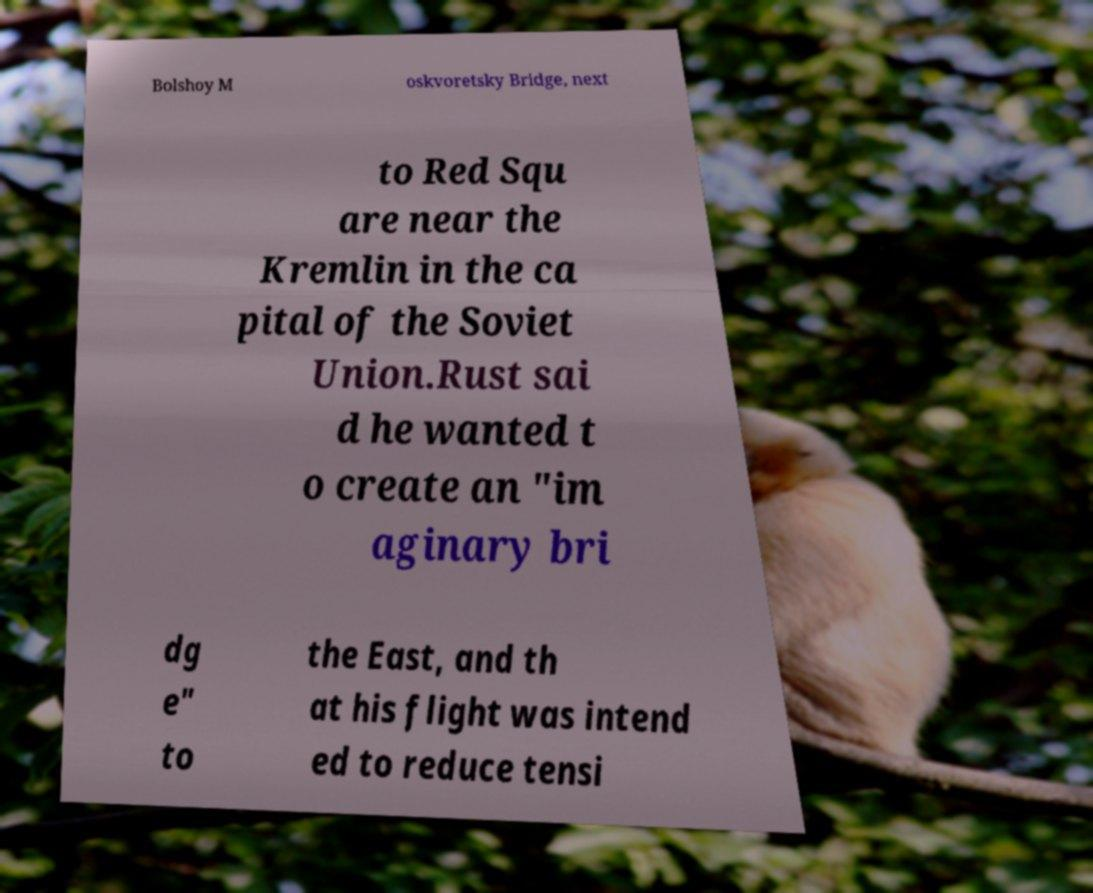What messages or text are displayed in this image? I need them in a readable, typed format. Bolshoy M oskvoretsky Bridge, next to Red Squ are near the Kremlin in the ca pital of the Soviet Union.Rust sai d he wanted t o create an "im aginary bri dg e" to the East, and th at his flight was intend ed to reduce tensi 